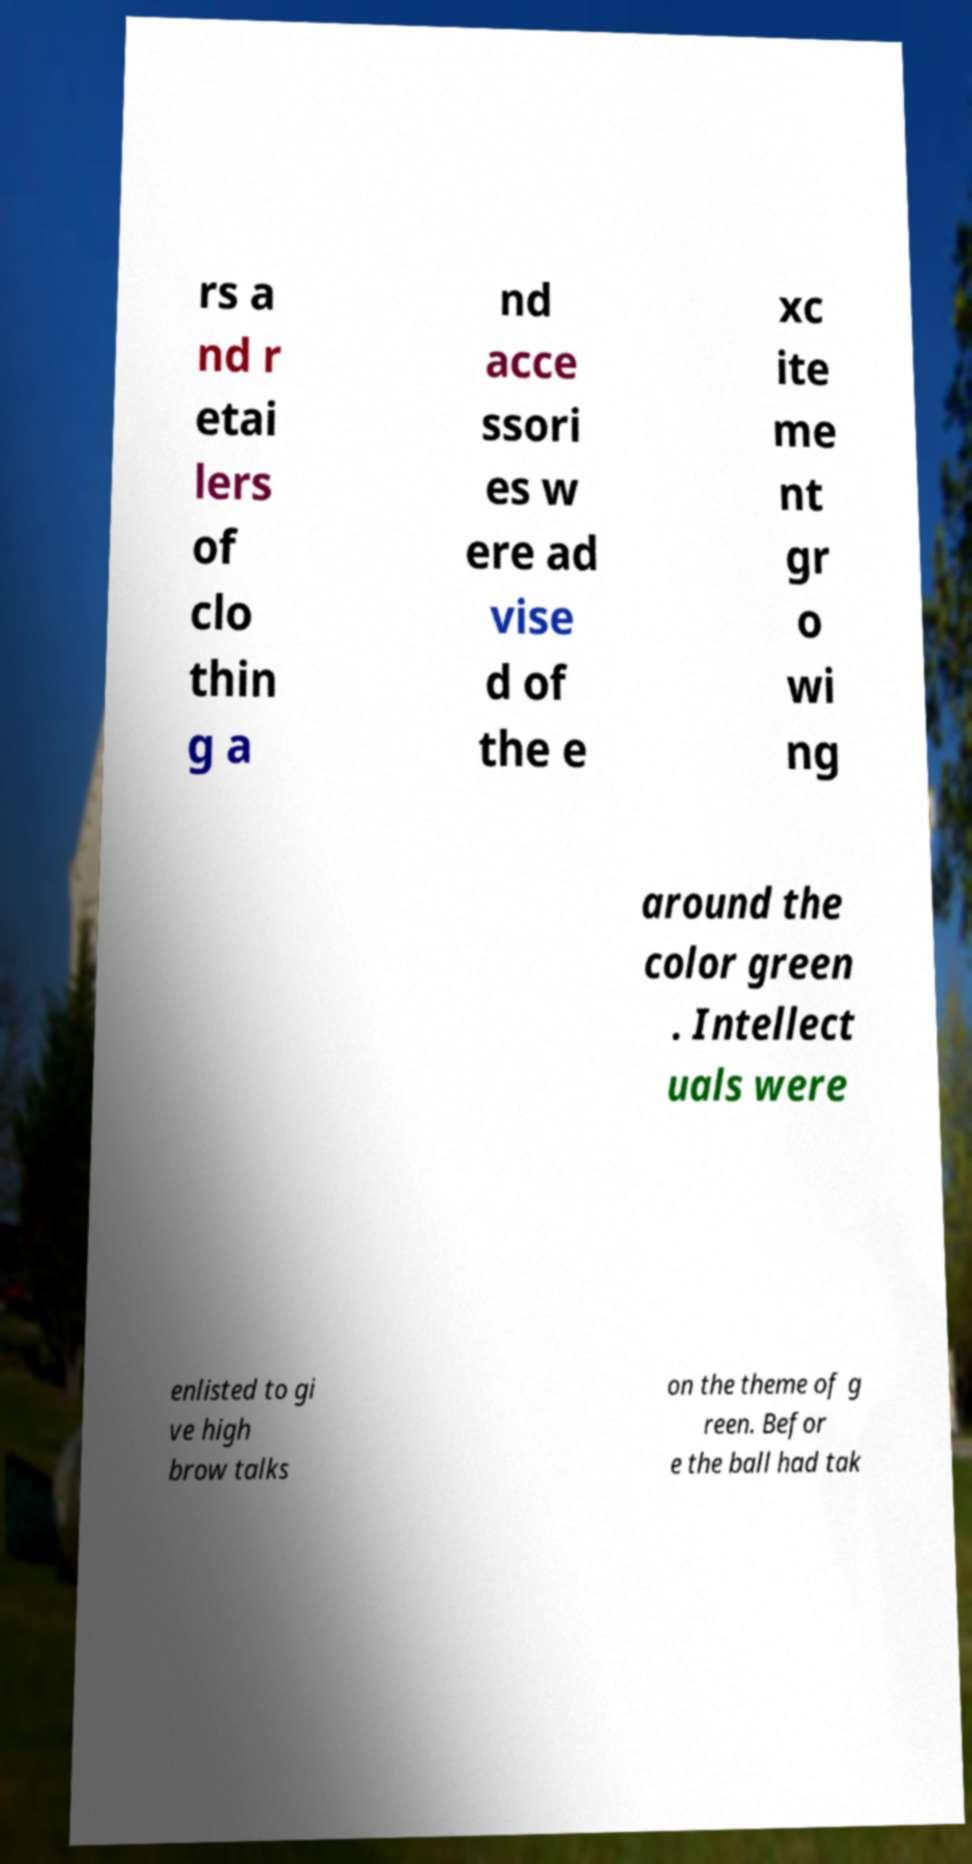Can you accurately transcribe the text from the provided image for me? rs a nd r etai lers of clo thin g a nd acce ssori es w ere ad vise d of the e xc ite me nt gr o wi ng around the color green . Intellect uals were enlisted to gi ve high brow talks on the theme of g reen. Befor e the ball had tak 